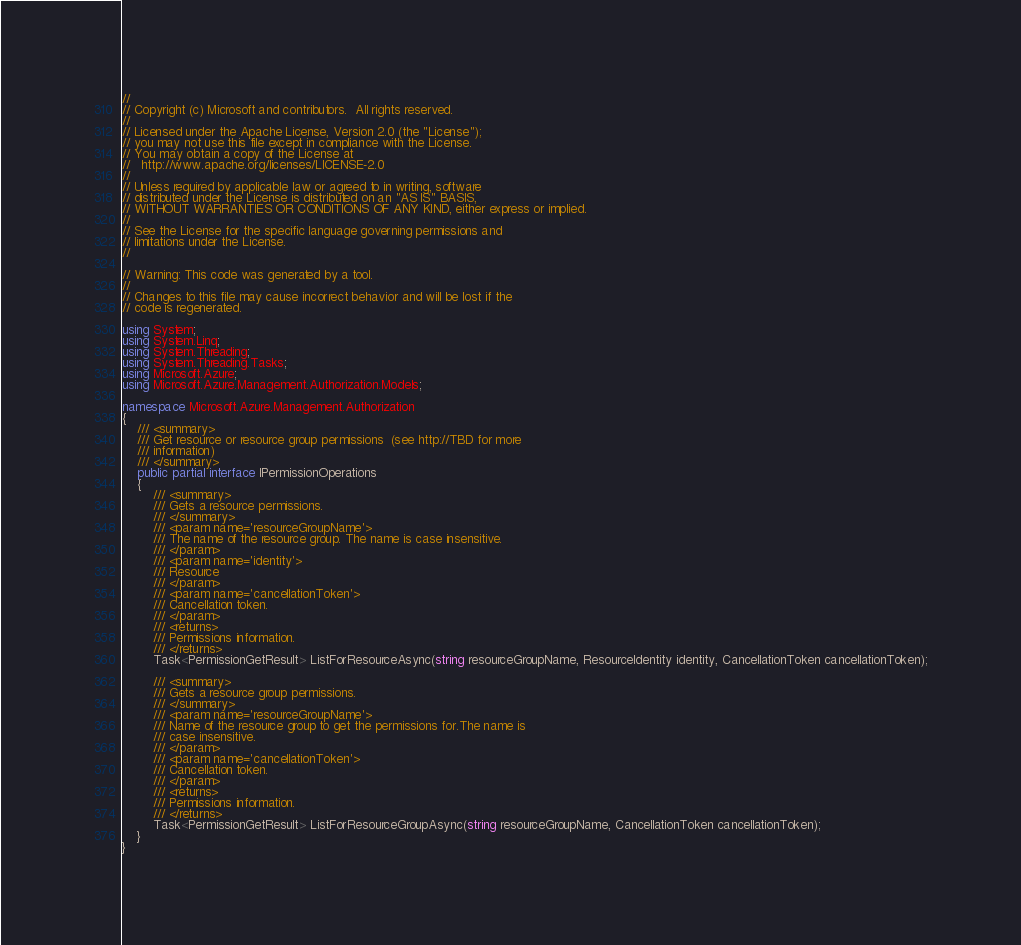Convert code to text. <code><loc_0><loc_0><loc_500><loc_500><_C#_>// 
// Copyright (c) Microsoft and contributors.  All rights reserved.
// 
// Licensed under the Apache License, Version 2.0 (the "License");
// you may not use this file except in compliance with the License.
// You may obtain a copy of the License at
//   http://www.apache.org/licenses/LICENSE-2.0
// 
// Unless required by applicable law or agreed to in writing, software
// distributed under the License is distributed on an "AS IS" BASIS,
// WITHOUT WARRANTIES OR CONDITIONS OF ANY KIND, either express or implied.
// 
// See the License for the specific language governing permissions and
// limitations under the License.
// 

// Warning: This code was generated by a tool.
// 
// Changes to this file may cause incorrect behavior and will be lost if the
// code is regenerated.

using System;
using System.Linq;
using System.Threading;
using System.Threading.Tasks;
using Microsoft.Azure;
using Microsoft.Azure.Management.Authorization.Models;

namespace Microsoft.Azure.Management.Authorization
{
    /// <summary>
    /// Get resource or resource group permissions  (see http://TBD for more
    /// information)
    /// </summary>
    public partial interface IPermissionOperations
    {
        /// <summary>
        /// Gets a resource permissions.
        /// </summary>
        /// <param name='resourceGroupName'>
        /// The name of the resource group. The name is case insensitive.
        /// </param>
        /// <param name='identity'>
        /// Resource
        /// </param>
        /// <param name='cancellationToken'>
        /// Cancellation token.
        /// </param>
        /// <returns>
        /// Permissions information.
        /// </returns>
        Task<PermissionGetResult> ListForResourceAsync(string resourceGroupName, ResourceIdentity identity, CancellationToken cancellationToken);
        
        /// <summary>
        /// Gets a resource group permissions.
        /// </summary>
        /// <param name='resourceGroupName'>
        /// Name of the resource group to get the permissions for.The name is
        /// case insensitive.
        /// </param>
        /// <param name='cancellationToken'>
        /// Cancellation token.
        /// </param>
        /// <returns>
        /// Permissions information.
        /// </returns>
        Task<PermissionGetResult> ListForResourceGroupAsync(string resourceGroupName, CancellationToken cancellationToken);
    }
}
</code> 